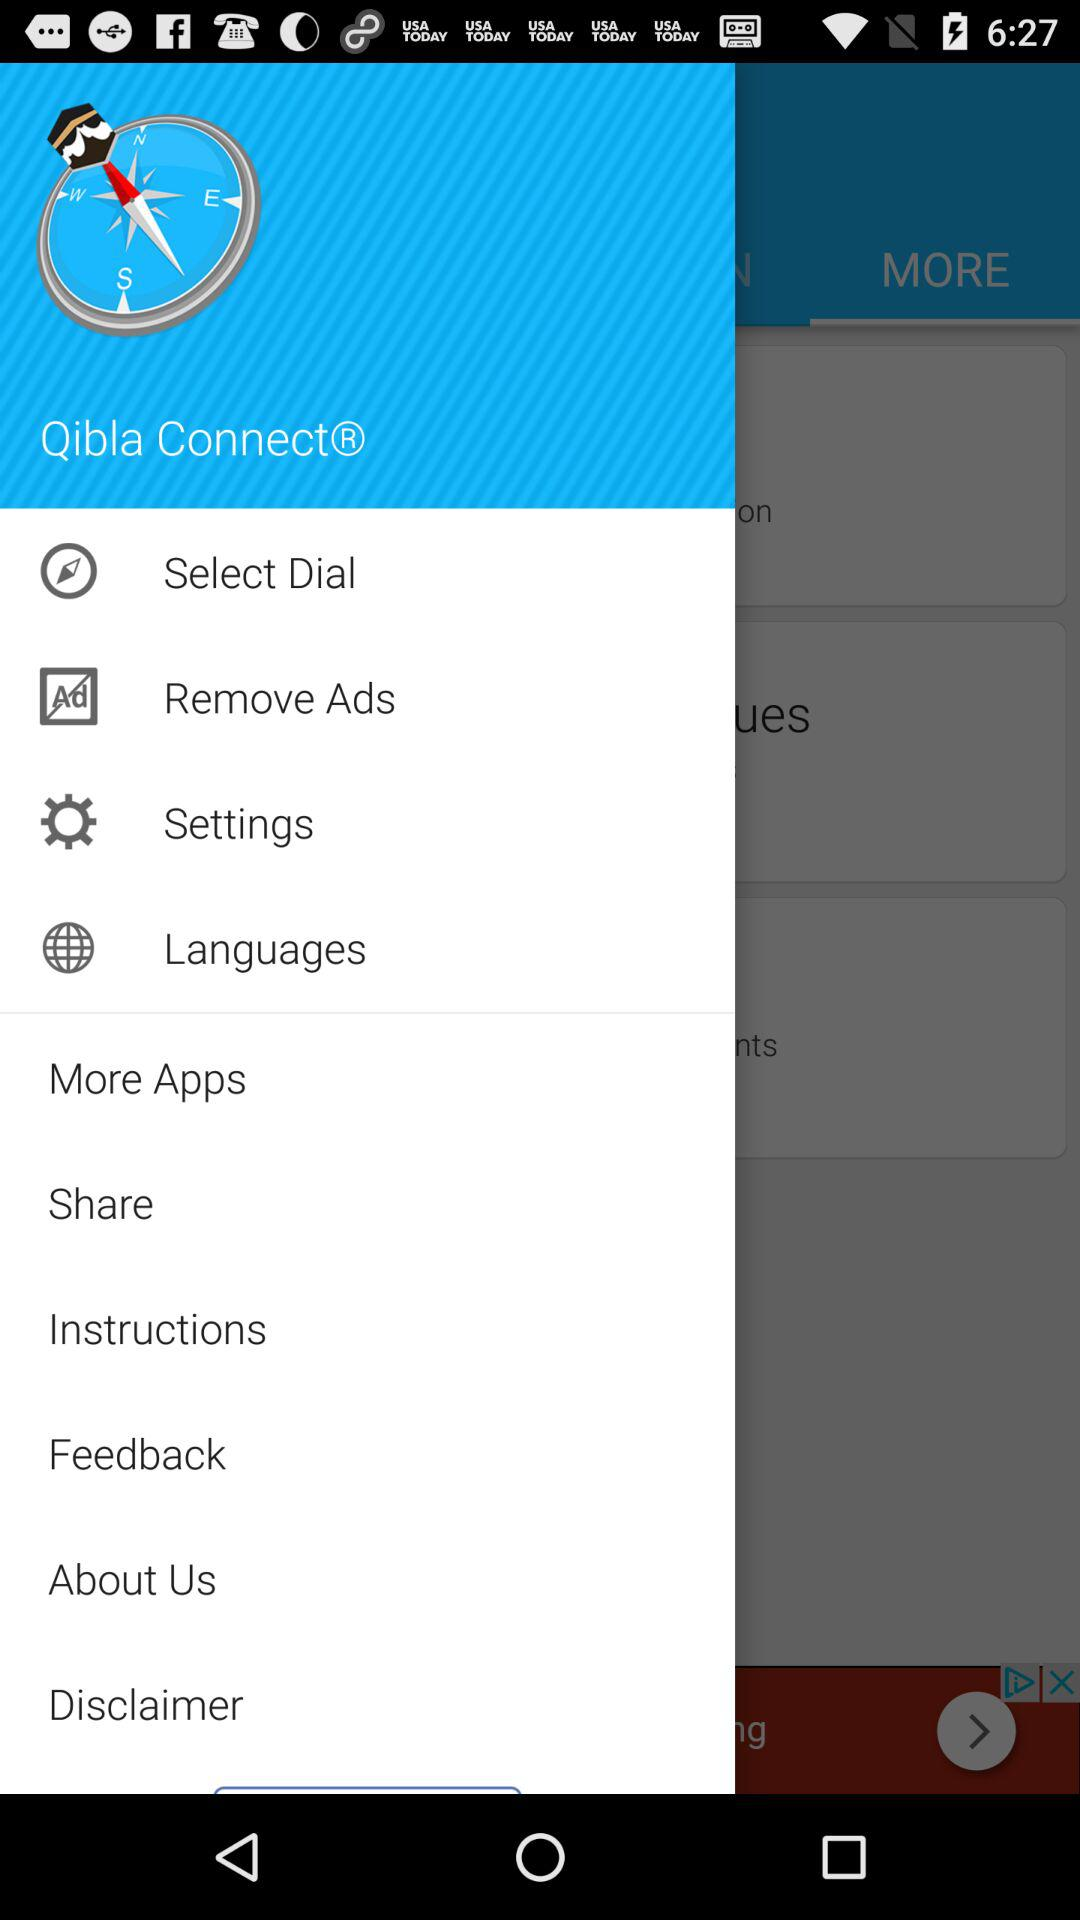How much does it cost to remove ads?
When the provided information is insufficient, respond with <no answer>. <no answer> 